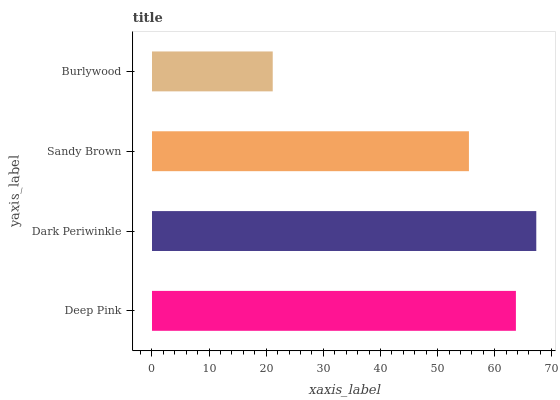Is Burlywood the minimum?
Answer yes or no. Yes. Is Dark Periwinkle the maximum?
Answer yes or no. Yes. Is Sandy Brown the minimum?
Answer yes or no. No. Is Sandy Brown the maximum?
Answer yes or no. No. Is Dark Periwinkle greater than Sandy Brown?
Answer yes or no. Yes. Is Sandy Brown less than Dark Periwinkle?
Answer yes or no. Yes. Is Sandy Brown greater than Dark Periwinkle?
Answer yes or no. No. Is Dark Periwinkle less than Sandy Brown?
Answer yes or no. No. Is Deep Pink the high median?
Answer yes or no. Yes. Is Sandy Brown the low median?
Answer yes or no. Yes. Is Burlywood the high median?
Answer yes or no. No. Is Burlywood the low median?
Answer yes or no. No. 